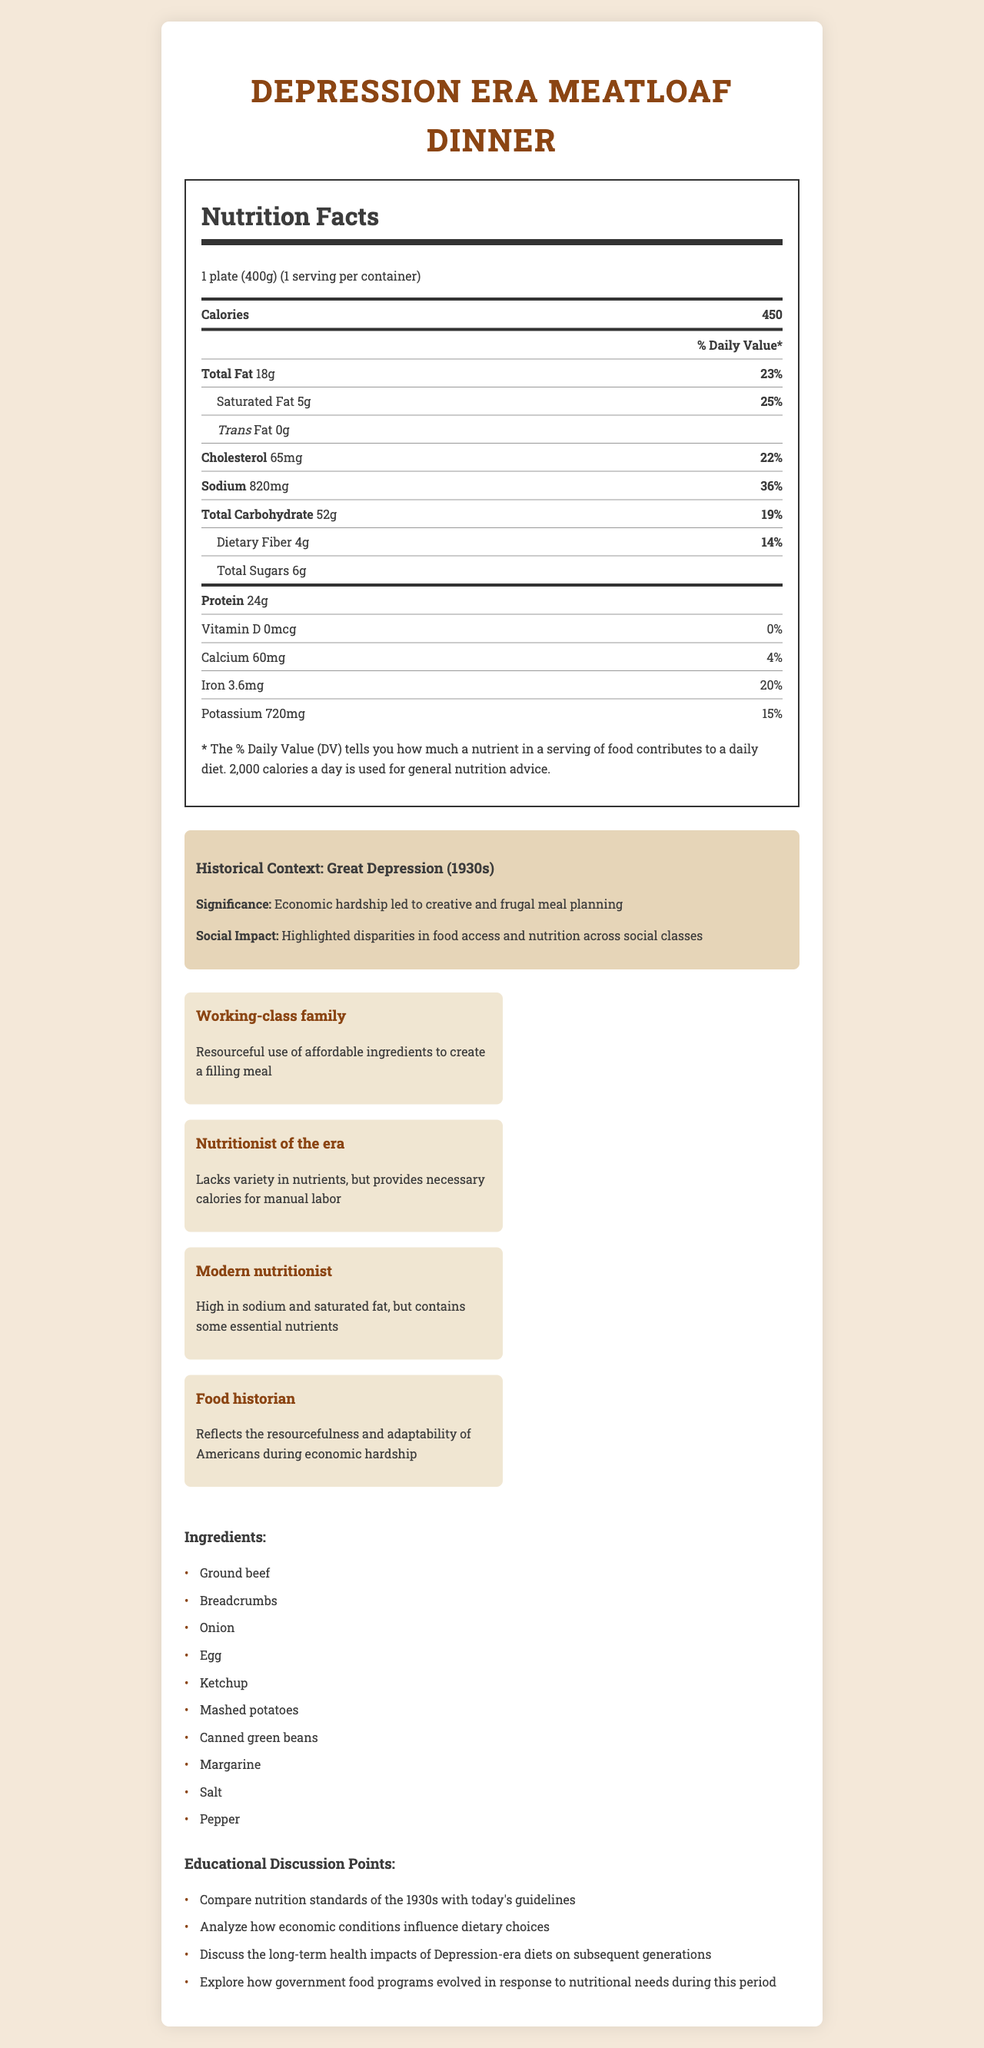what is the time period of the historical context? The historical context time period is specified as the Great Depression (1930s) in the document.
Answer: Great Depression (1930s) what is the ratio of sodium daily value to total fat daily value? The sodium daily value is 36%, and the total fat daily value is 23%. The ratio is 36% / 23% ≈ 1.57.
Answer: 1.57 name two ingredients in the Depression Era Meatloaf Dinner Two ingredients listed are ground beef and breadcrumbs.
Answer: Ground beef, Breadcrumbs how many servings are in one container? The document specifies that there is 1 serving per container.
Answer: 1 how does the perspective of a modern nutritionist differ from that of a Depression-era nutritionist? A modern nutritionist's opinion mentions that the meal is high in sodium and fat but contains some essential nutrients, while a Depression-era nutritionist notes it provides necessary calories for manual labor.
Answer: High in sodium and saturated fat vs. Provides necessary calories for manual labor what is the percentage of daily value of iron in the meal? The document lists the percentage of daily value for iron as 20%.
Answer: 20% how much dietary fiber is in the meal? A. 2g B. 4g C. 6g The nutrition facts state that the meal contains 4g of dietary fiber.
Answer: B which ingredient is not present in the Depression Era Meatloaf Dinner? A. Canned green beans B. Onion C. Chicken D. Egg The ingredients listed do not include chicken.
Answer: C is the meal high in vitamin D? The vitamin D content is listed as 0mcg with 0% daily value, indicating it is not high in vitamin D.
Answer: No summarize the main aspects of this document. The document offers a comprehensive view including nutrition facts, ingredients, and historical context. It also provides multiple perspectives on the meal and prompts educational discussions.
Answer: The document details the nutritional facts and ingredients of a Depression Era Meatloaf Dinner, along with various historical perspectives and discussion points. It highlights the significance of the Great Depression on meal planning, the nutritional analysis, and opinions from different viewpoints. what was the overall impact of Depression-era diets on future generations? The document does not provide information about the long-term health impacts of Depression-era diets on subsequent generations.
Answer: Cannot be determined 